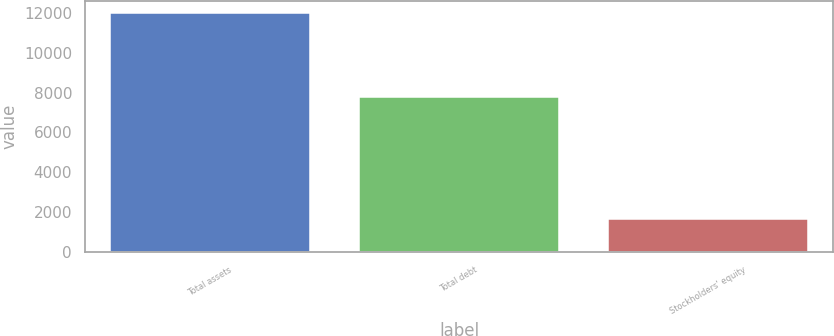Convert chart to OTSL. <chart><loc_0><loc_0><loc_500><loc_500><bar_chart><fcel>Total assets<fcel>Total debt<fcel>Stockholders' equity<nl><fcel>11988<fcel>7790<fcel>1648<nl></chart> 